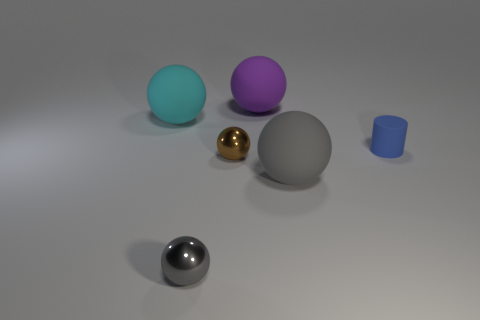How many other objects are the same material as the large gray sphere?
Offer a terse response. 3. Is the size of the cyan matte object the same as the cylinder in front of the big cyan sphere?
Give a very brief answer. No. What color is the shiny sphere behind the ball that is in front of the large gray matte sphere?
Your response must be concise. Brown. Do the cyan object and the gray rubber thing have the same size?
Your answer should be compact. Yes. The big rubber thing that is in front of the large purple matte object and to the left of the big gray matte ball is what color?
Ensure brevity in your answer.  Cyan. What is the size of the brown shiny thing?
Your answer should be compact. Small. Do the metal sphere in front of the tiny brown object and the tiny cylinder have the same color?
Your response must be concise. No. Is the number of metallic things in front of the tiny gray metal object greater than the number of tiny brown metal spheres on the right side of the brown metal ball?
Make the answer very short. No. Are there more small blocks than tiny brown spheres?
Your answer should be very brief. No. How big is the sphere that is both left of the small brown sphere and in front of the big cyan object?
Your answer should be compact. Small. 